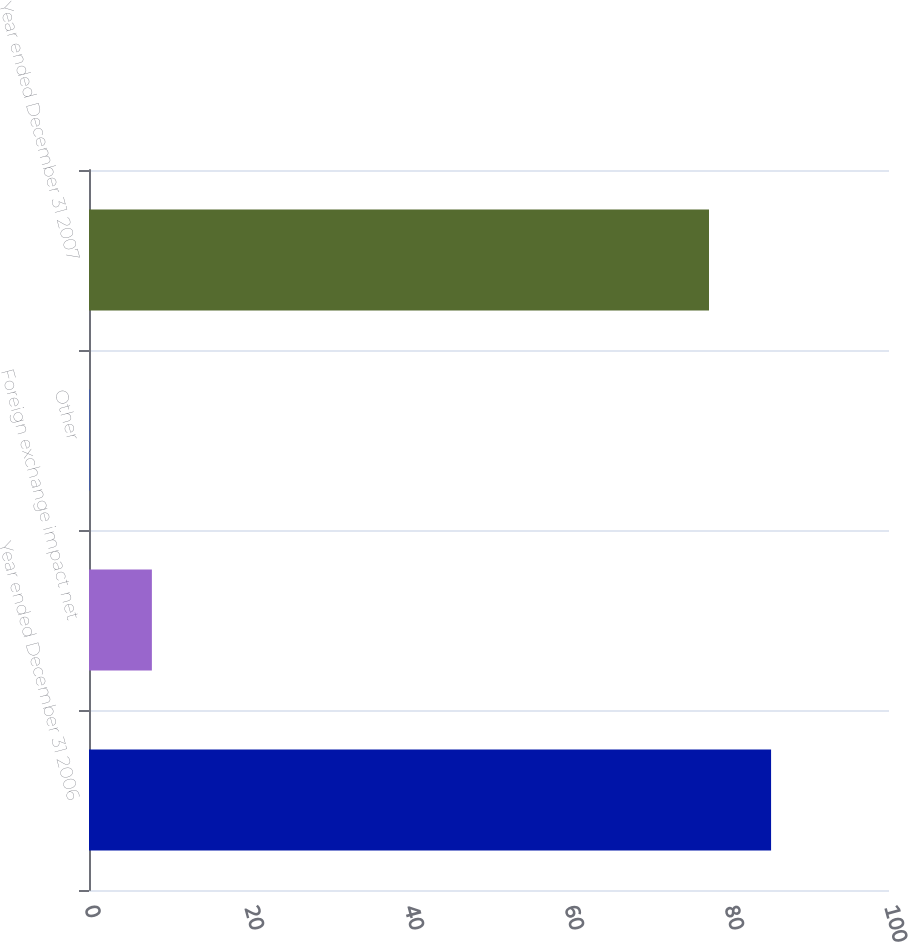<chart> <loc_0><loc_0><loc_500><loc_500><bar_chart><fcel>Year ended December 31 2006<fcel>Foreign exchange impact net<fcel>Other<fcel>Year ended December 31 2007<nl><fcel>85.26<fcel>7.86<fcel>0.1<fcel>77.5<nl></chart> 